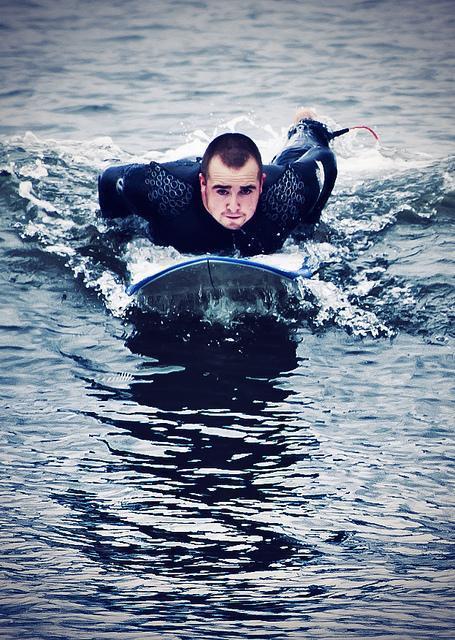How many surfboards are in the photo?
Give a very brief answer. 1. How many kites are in the air?
Give a very brief answer. 0. 